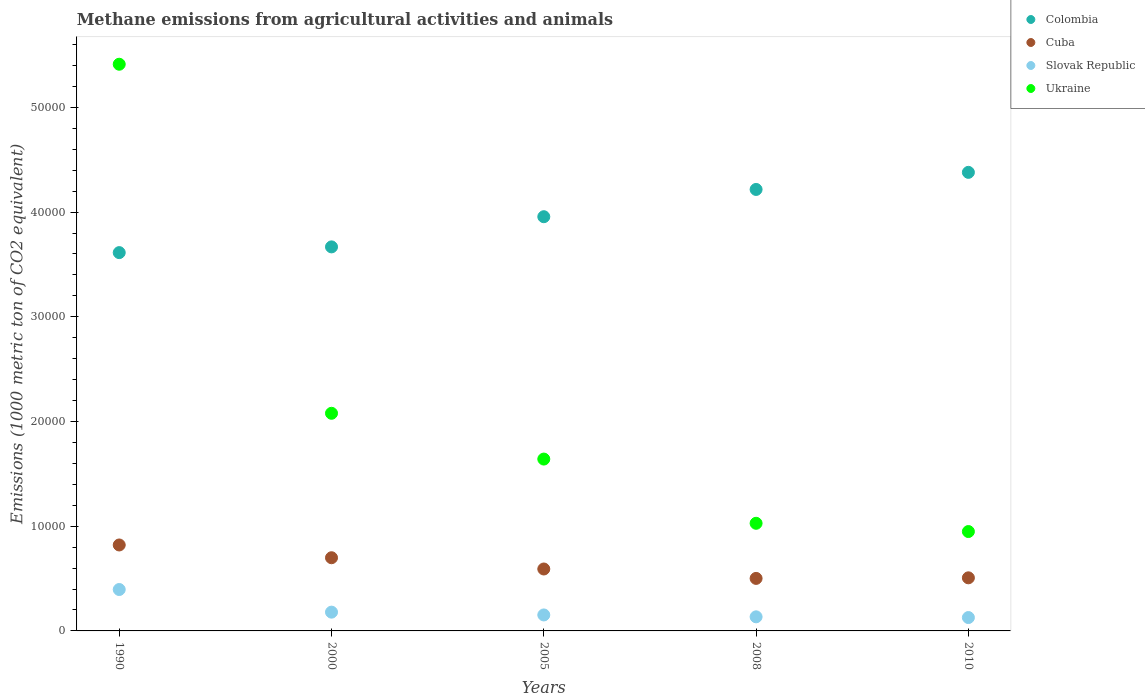What is the amount of methane emitted in Cuba in 2010?
Give a very brief answer. 5070.2. Across all years, what is the maximum amount of methane emitted in Ukraine?
Your answer should be very brief. 5.41e+04. Across all years, what is the minimum amount of methane emitted in Slovak Republic?
Keep it short and to the point. 1276.7. What is the total amount of methane emitted in Slovak Republic in the graph?
Your answer should be compact. 9896. What is the difference between the amount of methane emitted in Cuba in 1990 and that in 2008?
Ensure brevity in your answer.  3192.5. What is the difference between the amount of methane emitted in Cuba in 2000 and the amount of methane emitted in Slovak Republic in 2010?
Offer a terse response. 5711.6. What is the average amount of methane emitted in Cuba per year?
Give a very brief answer. 6238.96. In the year 1990, what is the difference between the amount of methane emitted in Slovak Republic and amount of methane emitted in Cuba?
Give a very brief answer. -4253. What is the ratio of the amount of methane emitted in Cuba in 1990 to that in 2008?
Make the answer very short. 1.64. Is the amount of methane emitted in Colombia in 2000 less than that in 2010?
Keep it short and to the point. Yes. Is the difference between the amount of methane emitted in Slovak Republic in 2000 and 2010 greater than the difference between the amount of methane emitted in Cuba in 2000 and 2010?
Keep it short and to the point. No. What is the difference between the highest and the second highest amount of methane emitted in Colombia?
Ensure brevity in your answer.  1632. What is the difference between the highest and the lowest amount of methane emitted in Colombia?
Provide a short and direct response. 7663.9. In how many years, is the amount of methane emitted in Colombia greater than the average amount of methane emitted in Colombia taken over all years?
Provide a succinct answer. 2. Is it the case that in every year, the sum of the amount of methane emitted in Slovak Republic and amount of methane emitted in Ukraine  is greater than the sum of amount of methane emitted in Colombia and amount of methane emitted in Cuba?
Your answer should be very brief. No. Does the amount of methane emitted in Slovak Republic monotonically increase over the years?
Provide a succinct answer. No. How many years are there in the graph?
Ensure brevity in your answer.  5. What is the difference between two consecutive major ticks on the Y-axis?
Offer a very short reply. 10000. Are the values on the major ticks of Y-axis written in scientific E-notation?
Provide a succinct answer. No. How many legend labels are there?
Your response must be concise. 4. How are the legend labels stacked?
Keep it short and to the point. Vertical. What is the title of the graph?
Give a very brief answer. Methane emissions from agricultural activities and animals. What is the label or title of the Y-axis?
Offer a terse response. Emissions (1000 metric ton of CO2 equivalent). What is the Emissions (1000 metric ton of CO2 equivalent) in Colombia in 1990?
Keep it short and to the point. 3.61e+04. What is the Emissions (1000 metric ton of CO2 equivalent) in Cuba in 1990?
Provide a succinct answer. 8207.5. What is the Emissions (1000 metric ton of CO2 equivalent) in Slovak Republic in 1990?
Offer a terse response. 3954.5. What is the Emissions (1000 metric ton of CO2 equivalent) in Ukraine in 1990?
Make the answer very short. 5.41e+04. What is the Emissions (1000 metric ton of CO2 equivalent) of Colombia in 2000?
Give a very brief answer. 3.67e+04. What is the Emissions (1000 metric ton of CO2 equivalent) in Cuba in 2000?
Your response must be concise. 6988.3. What is the Emissions (1000 metric ton of CO2 equivalent) of Slovak Republic in 2000?
Your response must be concise. 1793.2. What is the Emissions (1000 metric ton of CO2 equivalent) of Ukraine in 2000?
Ensure brevity in your answer.  2.08e+04. What is the Emissions (1000 metric ton of CO2 equivalent) of Colombia in 2005?
Offer a terse response. 3.96e+04. What is the Emissions (1000 metric ton of CO2 equivalent) in Cuba in 2005?
Provide a short and direct response. 5913.8. What is the Emissions (1000 metric ton of CO2 equivalent) of Slovak Republic in 2005?
Provide a short and direct response. 1525.9. What is the Emissions (1000 metric ton of CO2 equivalent) of Ukraine in 2005?
Offer a terse response. 1.64e+04. What is the Emissions (1000 metric ton of CO2 equivalent) in Colombia in 2008?
Make the answer very short. 4.22e+04. What is the Emissions (1000 metric ton of CO2 equivalent) in Cuba in 2008?
Your response must be concise. 5015. What is the Emissions (1000 metric ton of CO2 equivalent) of Slovak Republic in 2008?
Ensure brevity in your answer.  1345.7. What is the Emissions (1000 metric ton of CO2 equivalent) in Ukraine in 2008?
Provide a short and direct response. 1.03e+04. What is the Emissions (1000 metric ton of CO2 equivalent) in Colombia in 2010?
Your response must be concise. 4.38e+04. What is the Emissions (1000 metric ton of CO2 equivalent) in Cuba in 2010?
Make the answer very short. 5070.2. What is the Emissions (1000 metric ton of CO2 equivalent) in Slovak Republic in 2010?
Your answer should be very brief. 1276.7. What is the Emissions (1000 metric ton of CO2 equivalent) of Ukraine in 2010?
Your answer should be compact. 9489.8. Across all years, what is the maximum Emissions (1000 metric ton of CO2 equivalent) in Colombia?
Your answer should be very brief. 4.38e+04. Across all years, what is the maximum Emissions (1000 metric ton of CO2 equivalent) of Cuba?
Offer a terse response. 8207.5. Across all years, what is the maximum Emissions (1000 metric ton of CO2 equivalent) in Slovak Republic?
Make the answer very short. 3954.5. Across all years, what is the maximum Emissions (1000 metric ton of CO2 equivalent) of Ukraine?
Your answer should be compact. 5.41e+04. Across all years, what is the minimum Emissions (1000 metric ton of CO2 equivalent) in Colombia?
Make the answer very short. 3.61e+04. Across all years, what is the minimum Emissions (1000 metric ton of CO2 equivalent) of Cuba?
Ensure brevity in your answer.  5015. Across all years, what is the minimum Emissions (1000 metric ton of CO2 equivalent) in Slovak Republic?
Your answer should be very brief. 1276.7. Across all years, what is the minimum Emissions (1000 metric ton of CO2 equivalent) in Ukraine?
Offer a very short reply. 9489.8. What is the total Emissions (1000 metric ton of CO2 equivalent) of Colombia in the graph?
Offer a terse response. 1.98e+05. What is the total Emissions (1000 metric ton of CO2 equivalent) of Cuba in the graph?
Offer a terse response. 3.12e+04. What is the total Emissions (1000 metric ton of CO2 equivalent) in Slovak Republic in the graph?
Offer a very short reply. 9896. What is the total Emissions (1000 metric ton of CO2 equivalent) in Ukraine in the graph?
Offer a terse response. 1.11e+05. What is the difference between the Emissions (1000 metric ton of CO2 equivalent) in Colombia in 1990 and that in 2000?
Provide a short and direct response. -546.7. What is the difference between the Emissions (1000 metric ton of CO2 equivalent) in Cuba in 1990 and that in 2000?
Your response must be concise. 1219.2. What is the difference between the Emissions (1000 metric ton of CO2 equivalent) of Slovak Republic in 1990 and that in 2000?
Your answer should be very brief. 2161.3. What is the difference between the Emissions (1000 metric ton of CO2 equivalent) in Ukraine in 1990 and that in 2000?
Ensure brevity in your answer.  3.33e+04. What is the difference between the Emissions (1000 metric ton of CO2 equivalent) in Colombia in 1990 and that in 2005?
Provide a short and direct response. -3428.3. What is the difference between the Emissions (1000 metric ton of CO2 equivalent) in Cuba in 1990 and that in 2005?
Offer a terse response. 2293.7. What is the difference between the Emissions (1000 metric ton of CO2 equivalent) in Slovak Republic in 1990 and that in 2005?
Give a very brief answer. 2428.6. What is the difference between the Emissions (1000 metric ton of CO2 equivalent) in Ukraine in 1990 and that in 2005?
Make the answer very short. 3.77e+04. What is the difference between the Emissions (1000 metric ton of CO2 equivalent) in Colombia in 1990 and that in 2008?
Your answer should be very brief. -6031.9. What is the difference between the Emissions (1000 metric ton of CO2 equivalent) in Cuba in 1990 and that in 2008?
Offer a very short reply. 3192.5. What is the difference between the Emissions (1000 metric ton of CO2 equivalent) in Slovak Republic in 1990 and that in 2008?
Ensure brevity in your answer.  2608.8. What is the difference between the Emissions (1000 metric ton of CO2 equivalent) of Ukraine in 1990 and that in 2008?
Your answer should be compact. 4.38e+04. What is the difference between the Emissions (1000 metric ton of CO2 equivalent) of Colombia in 1990 and that in 2010?
Your answer should be compact. -7663.9. What is the difference between the Emissions (1000 metric ton of CO2 equivalent) in Cuba in 1990 and that in 2010?
Your answer should be very brief. 3137.3. What is the difference between the Emissions (1000 metric ton of CO2 equivalent) of Slovak Republic in 1990 and that in 2010?
Give a very brief answer. 2677.8. What is the difference between the Emissions (1000 metric ton of CO2 equivalent) in Ukraine in 1990 and that in 2010?
Ensure brevity in your answer.  4.46e+04. What is the difference between the Emissions (1000 metric ton of CO2 equivalent) of Colombia in 2000 and that in 2005?
Your answer should be very brief. -2881.6. What is the difference between the Emissions (1000 metric ton of CO2 equivalent) in Cuba in 2000 and that in 2005?
Provide a succinct answer. 1074.5. What is the difference between the Emissions (1000 metric ton of CO2 equivalent) of Slovak Republic in 2000 and that in 2005?
Your answer should be very brief. 267.3. What is the difference between the Emissions (1000 metric ton of CO2 equivalent) in Ukraine in 2000 and that in 2005?
Your answer should be compact. 4372.1. What is the difference between the Emissions (1000 metric ton of CO2 equivalent) of Colombia in 2000 and that in 2008?
Your answer should be very brief. -5485.2. What is the difference between the Emissions (1000 metric ton of CO2 equivalent) of Cuba in 2000 and that in 2008?
Ensure brevity in your answer.  1973.3. What is the difference between the Emissions (1000 metric ton of CO2 equivalent) of Slovak Republic in 2000 and that in 2008?
Offer a terse response. 447.5. What is the difference between the Emissions (1000 metric ton of CO2 equivalent) in Ukraine in 2000 and that in 2008?
Your response must be concise. 1.05e+04. What is the difference between the Emissions (1000 metric ton of CO2 equivalent) of Colombia in 2000 and that in 2010?
Provide a succinct answer. -7117.2. What is the difference between the Emissions (1000 metric ton of CO2 equivalent) of Cuba in 2000 and that in 2010?
Make the answer very short. 1918.1. What is the difference between the Emissions (1000 metric ton of CO2 equivalent) of Slovak Republic in 2000 and that in 2010?
Your answer should be compact. 516.5. What is the difference between the Emissions (1000 metric ton of CO2 equivalent) of Ukraine in 2000 and that in 2010?
Your answer should be very brief. 1.13e+04. What is the difference between the Emissions (1000 metric ton of CO2 equivalent) of Colombia in 2005 and that in 2008?
Give a very brief answer. -2603.6. What is the difference between the Emissions (1000 metric ton of CO2 equivalent) of Cuba in 2005 and that in 2008?
Keep it short and to the point. 898.8. What is the difference between the Emissions (1000 metric ton of CO2 equivalent) of Slovak Republic in 2005 and that in 2008?
Your answer should be very brief. 180.2. What is the difference between the Emissions (1000 metric ton of CO2 equivalent) of Ukraine in 2005 and that in 2008?
Provide a succinct answer. 6133.4. What is the difference between the Emissions (1000 metric ton of CO2 equivalent) of Colombia in 2005 and that in 2010?
Offer a terse response. -4235.6. What is the difference between the Emissions (1000 metric ton of CO2 equivalent) of Cuba in 2005 and that in 2010?
Offer a very short reply. 843.6. What is the difference between the Emissions (1000 metric ton of CO2 equivalent) in Slovak Republic in 2005 and that in 2010?
Provide a short and direct response. 249.2. What is the difference between the Emissions (1000 metric ton of CO2 equivalent) of Ukraine in 2005 and that in 2010?
Your answer should be compact. 6921.6. What is the difference between the Emissions (1000 metric ton of CO2 equivalent) in Colombia in 2008 and that in 2010?
Your answer should be very brief. -1632. What is the difference between the Emissions (1000 metric ton of CO2 equivalent) of Cuba in 2008 and that in 2010?
Your answer should be compact. -55.2. What is the difference between the Emissions (1000 metric ton of CO2 equivalent) of Slovak Republic in 2008 and that in 2010?
Your answer should be very brief. 69. What is the difference between the Emissions (1000 metric ton of CO2 equivalent) of Ukraine in 2008 and that in 2010?
Ensure brevity in your answer.  788.2. What is the difference between the Emissions (1000 metric ton of CO2 equivalent) in Colombia in 1990 and the Emissions (1000 metric ton of CO2 equivalent) in Cuba in 2000?
Provide a short and direct response. 2.91e+04. What is the difference between the Emissions (1000 metric ton of CO2 equivalent) in Colombia in 1990 and the Emissions (1000 metric ton of CO2 equivalent) in Slovak Republic in 2000?
Your answer should be very brief. 3.43e+04. What is the difference between the Emissions (1000 metric ton of CO2 equivalent) of Colombia in 1990 and the Emissions (1000 metric ton of CO2 equivalent) of Ukraine in 2000?
Make the answer very short. 1.53e+04. What is the difference between the Emissions (1000 metric ton of CO2 equivalent) of Cuba in 1990 and the Emissions (1000 metric ton of CO2 equivalent) of Slovak Republic in 2000?
Ensure brevity in your answer.  6414.3. What is the difference between the Emissions (1000 metric ton of CO2 equivalent) in Cuba in 1990 and the Emissions (1000 metric ton of CO2 equivalent) in Ukraine in 2000?
Your answer should be very brief. -1.26e+04. What is the difference between the Emissions (1000 metric ton of CO2 equivalent) of Slovak Republic in 1990 and the Emissions (1000 metric ton of CO2 equivalent) of Ukraine in 2000?
Provide a succinct answer. -1.68e+04. What is the difference between the Emissions (1000 metric ton of CO2 equivalent) in Colombia in 1990 and the Emissions (1000 metric ton of CO2 equivalent) in Cuba in 2005?
Keep it short and to the point. 3.02e+04. What is the difference between the Emissions (1000 metric ton of CO2 equivalent) of Colombia in 1990 and the Emissions (1000 metric ton of CO2 equivalent) of Slovak Republic in 2005?
Offer a terse response. 3.46e+04. What is the difference between the Emissions (1000 metric ton of CO2 equivalent) in Colombia in 1990 and the Emissions (1000 metric ton of CO2 equivalent) in Ukraine in 2005?
Offer a terse response. 1.97e+04. What is the difference between the Emissions (1000 metric ton of CO2 equivalent) in Cuba in 1990 and the Emissions (1000 metric ton of CO2 equivalent) in Slovak Republic in 2005?
Offer a very short reply. 6681.6. What is the difference between the Emissions (1000 metric ton of CO2 equivalent) in Cuba in 1990 and the Emissions (1000 metric ton of CO2 equivalent) in Ukraine in 2005?
Your response must be concise. -8203.9. What is the difference between the Emissions (1000 metric ton of CO2 equivalent) in Slovak Republic in 1990 and the Emissions (1000 metric ton of CO2 equivalent) in Ukraine in 2005?
Make the answer very short. -1.25e+04. What is the difference between the Emissions (1000 metric ton of CO2 equivalent) in Colombia in 1990 and the Emissions (1000 metric ton of CO2 equivalent) in Cuba in 2008?
Keep it short and to the point. 3.11e+04. What is the difference between the Emissions (1000 metric ton of CO2 equivalent) of Colombia in 1990 and the Emissions (1000 metric ton of CO2 equivalent) of Slovak Republic in 2008?
Offer a terse response. 3.48e+04. What is the difference between the Emissions (1000 metric ton of CO2 equivalent) in Colombia in 1990 and the Emissions (1000 metric ton of CO2 equivalent) in Ukraine in 2008?
Your answer should be very brief. 2.58e+04. What is the difference between the Emissions (1000 metric ton of CO2 equivalent) in Cuba in 1990 and the Emissions (1000 metric ton of CO2 equivalent) in Slovak Republic in 2008?
Ensure brevity in your answer.  6861.8. What is the difference between the Emissions (1000 metric ton of CO2 equivalent) of Cuba in 1990 and the Emissions (1000 metric ton of CO2 equivalent) of Ukraine in 2008?
Offer a terse response. -2070.5. What is the difference between the Emissions (1000 metric ton of CO2 equivalent) of Slovak Republic in 1990 and the Emissions (1000 metric ton of CO2 equivalent) of Ukraine in 2008?
Provide a succinct answer. -6323.5. What is the difference between the Emissions (1000 metric ton of CO2 equivalent) in Colombia in 1990 and the Emissions (1000 metric ton of CO2 equivalent) in Cuba in 2010?
Offer a terse response. 3.11e+04. What is the difference between the Emissions (1000 metric ton of CO2 equivalent) of Colombia in 1990 and the Emissions (1000 metric ton of CO2 equivalent) of Slovak Republic in 2010?
Provide a short and direct response. 3.49e+04. What is the difference between the Emissions (1000 metric ton of CO2 equivalent) in Colombia in 1990 and the Emissions (1000 metric ton of CO2 equivalent) in Ukraine in 2010?
Keep it short and to the point. 2.66e+04. What is the difference between the Emissions (1000 metric ton of CO2 equivalent) in Cuba in 1990 and the Emissions (1000 metric ton of CO2 equivalent) in Slovak Republic in 2010?
Your response must be concise. 6930.8. What is the difference between the Emissions (1000 metric ton of CO2 equivalent) of Cuba in 1990 and the Emissions (1000 metric ton of CO2 equivalent) of Ukraine in 2010?
Offer a very short reply. -1282.3. What is the difference between the Emissions (1000 metric ton of CO2 equivalent) in Slovak Republic in 1990 and the Emissions (1000 metric ton of CO2 equivalent) in Ukraine in 2010?
Offer a terse response. -5535.3. What is the difference between the Emissions (1000 metric ton of CO2 equivalent) in Colombia in 2000 and the Emissions (1000 metric ton of CO2 equivalent) in Cuba in 2005?
Make the answer very short. 3.08e+04. What is the difference between the Emissions (1000 metric ton of CO2 equivalent) of Colombia in 2000 and the Emissions (1000 metric ton of CO2 equivalent) of Slovak Republic in 2005?
Keep it short and to the point. 3.51e+04. What is the difference between the Emissions (1000 metric ton of CO2 equivalent) in Colombia in 2000 and the Emissions (1000 metric ton of CO2 equivalent) in Ukraine in 2005?
Your response must be concise. 2.03e+04. What is the difference between the Emissions (1000 metric ton of CO2 equivalent) of Cuba in 2000 and the Emissions (1000 metric ton of CO2 equivalent) of Slovak Republic in 2005?
Your answer should be compact. 5462.4. What is the difference between the Emissions (1000 metric ton of CO2 equivalent) in Cuba in 2000 and the Emissions (1000 metric ton of CO2 equivalent) in Ukraine in 2005?
Provide a short and direct response. -9423.1. What is the difference between the Emissions (1000 metric ton of CO2 equivalent) in Slovak Republic in 2000 and the Emissions (1000 metric ton of CO2 equivalent) in Ukraine in 2005?
Your response must be concise. -1.46e+04. What is the difference between the Emissions (1000 metric ton of CO2 equivalent) of Colombia in 2000 and the Emissions (1000 metric ton of CO2 equivalent) of Cuba in 2008?
Your answer should be compact. 3.17e+04. What is the difference between the Emissions (1000 metric ton of CO2 equivalent) of Colombia in 2000 and the Emissions (1000 metric ton of CO2 equivalent) of Slovak Republic in 2008?
Ensure brevity in your answer.  3.53e+04. What is the difference between the Emissions (1000 metric ton of CO2 equivalent) in Colombia in 2000 and the Emissions (1000 metric ton of CO2 equivalent) in Ukraine in 2008?
Make the answer very short. 2.64e+04. What is the difference between the Emissions (1000 metric ton of CO2 equivalent) in Cuba in 2000 and the Emissions (1000 metric ton of CO2 equivalent) in Slovak Republic in 2008?
Your response must be concise. 5642.6. What is the difference between the Emissions (1000 metric ton of CO2 equivalent) of Cuba in 2000 and the Emissions (1000 metric ton of CO2 equivalent) of Ukraine in 2008?
Keep it short and to the point. -3289.7. What is the difference between the Emissions (1000 metric ton of CO2 equivalent) of Slovak Republic in 2000 and the Emissions (1000 metric ton of CO2 equivalent) of Ukraine in 2008?
Provide a succinct answer. -8484.8. What is the difference between the Emissions (1000 metric ton of CO2 equivalent) of Colombia in 2000 and the Emissions (1000 metric ton of CO2 equivalent) of Cuba in 2010?
Your answer should be compact. 3.16e+04. What is the difference between the Emissions (1000 metric ton of CO2 equivalent) in Colombia in 2000 and the Emissions (1000 metric ton of CO2 equivalent) in Slovak Republic in 2010?
Your answer should be very brief. 3.54e+04. What is the difference between the Emissions (1000 metric ton of CO2 equivalent) in Colombia in 2000 and the Emissions (1000 metric ton of CO2 equivalent) in Ukraine in 2010?
Ensure brevity in your answer.  2.72e+04. What is the difference between the Emissions (1000 metric ton of CO2 equivalent) in Cuba in 2000 and the Emissions (1000 metric ton of CO2 equivalent) in Slovak Republic in 2010?
Keep it short and to the point. 5711.6. What is the difference between the Emissions (1000 metric ton of CO2 equivalent) of Cuba in 2000 and the Emissions (1000 metric ton of CO2 equivalent) of Ukraine in 2010?
Offer a very short reply. -2501.5. What is the difference between the Emissions (1000 metric ton of CO2 equivalent) of Slovak Republic in 2000 and the Emissions (1000 metric ton of CO2 equivalent) of Ukraine in 2010?
Give a very brief answer. -7696.6. What is the difference between the Emissions (1000 metric ton of CO2 equivalent) in Colombia in 2005 and the Emissions (1000 metric ton of CO2 equivalent) in Cuba in 2008?
Make the answer very short. 3.45e+04. What is the difference between the Emissions (1000 metric ton of CO2 equivalent) of Colombia in 2005 and the Emissions (1000 metric ton of CO2 equivalent) of Slovak Republic in 2008?
Provide a succinct answer. 3.82e+04. What is the difference between the Emissions (1000 metric ton of CO2 equivalent) in Colombia in 2005 and the Emissions (1000 metric ton of CO2 equivalent) in Ukraine in 2008?
Your response must be concise. 2.93e+04. What is the difference between the Emissions (1000 metric ton of CO2 equivalent) in Cuba in 2005 and the Emissions (1000 metric ton of CO2 equivalent) in Slovak Republic in 2008?
Provide a short and direct response. 4568.1. What is the difference between the Emissions (1000 metric ton of CO2 equivalent) of Cuba in 2005 and the Emissions (1000 metric ton of CO2 equivalent) of Ukraine in 2008?
Keep it short and to the point. -4364.2. What is the difference between the Emissions (1000 metric ton of CO2 equivalent) in Slovak Republic in 2005 and the Emissions (1000 metric ton of CO2 equivalent) in Ukraine in 2008?
Offer a terse response. -8752.1. What is the difference between the Emissions (1000 metric ton of CO2 equivalent) in Colombia in 2005 and the Emissions (1000 metric ton of CO2 equivalent) in Cuba in 2010?
Provide a succinct answer. 3.45e+04. What is the difference between the Emissions (1000 metric ton of CO2 equivalent) of Colombia in 2005 and the Emissions (1000 metric ton of CO2 equivalent) of Slovak Republic in 2010?
Offer a very short reply. 3.83e+04. What is the difference between the Emissions (1000 metric ton of CO2 equivalent) of Colombia in 2005 and the Emissions (1000 metric ton of CO2 equivalent) of Ukraine in 2010?
Offer a terse response. 3.01e+04. What is the difference between the Emissions (1000 metric ton of CO2 equivalent) of Cuba in 2005 and the Emissions (1000 metric ton of CO2 equivalent) of Slovak Republic in 2010?
Make the answer very short. 4637.1. What is the difference between the Emissions (1000 metric ton of CO2 equivalent) of Cuba in 2005 and the Emissions (1000 metric ton of CO2 equivalent) of Ukraine in 2010?
Your answer should be compact. -3576. What is the difference between the Emissions (1000 metric ton of CO2 equivalent) in Slovak Republic in 2005 and the Emissions (1000 metric ton of CO2 equivalent) in Ukraine in 2010?
Provide a short and direct response. -7963.9. What is the difference between the Emissions (1000 metric ton of CO2 equivalent) of Colombia in 2008 and the Emissions (1000 metric ton of CO2 equivalent) of Cuba in 2010?
Make the answer very short. 3.71e+04. What is the difference between the Emissions (1000 metric ton of CO2 equivalent) of Colombia in 2008 and the Emissions (1000 metric ton of CO2 equivalent) of Slovak Republic in 2010?
Your answer should be compact. 4.09e+04. What is the difference between the Emissions (1000 metric ton of CO2 equivalent) of Colombia in 2008 and the Emissions (1000 metric ton of CO2 equivalent) of Ukraine in 2010?
Offer a very short reply. 3.27e+04. What is the difference between the Emissions (1000 metric ton of CO2 equivalent) of Cuba in 2008 and the Emissions (1000 metric ton of CO2 equivalent) of Slovak Republic in 2010?
Ensure brevity in your answer.  3738.3. What is the difference between the Emissions (1000 metric ton of CO2 equivalent) of Cuba in 2008 and the Emissions (1000 metric ton of CO2 equivalent) of Ukraine in 2010?
Keep it short and to the point. -4474.8. What is the difference between the Emissions (1000 metric ton of CO2 equivalent) in Slovak Republic in 2008 and the Emissions (1000 metric ton of CO2 equivalent) in Ukraine in 2010?
Your response must be concise. -8144.1. What is the average Emissions (1000 metric ton of CO2 equivalent) of Colombia per year?
Provide a succinct answer. 3.97e+04. What is the average Emissions (1000 metric ton of CO2 equivalent) in Cuba per year?
Keep it short and to the point. 6238.96. What is the average Emissions (1000 metric ton of CO2 equivalent) in Slovak Republic per year?
Offer a terse response. 1979.2. What is the average Emissions (1000 metric ton of CO2 equivalent) of Ukraine per year?
Provide a short and direct response. 2.22e+04. In the year 1990, what is the difference between the Emissions (1000 metric ton of CO2 equivalent) in Colombia and Emissions (1000 metric ton of CO2 equivalent) in Cuba?
Offer a very short reply. 2.79e+04. In the year 1990, what is the difference between the Emissions (1000 metric ton of CO2 equivalent) in Colombia and Emissions (1000 metric ton of CO2 equivalent) in Slovak Republic?
Make the answer very short. 3.22e+04. In the year 1990, what is the difference between the Emissions (1000 metric ton of CO2 equivalent) of Colombia and Emissions (1000 metric ton of CO2 equivalent) of Ukraine?
Make the answer very short. -1.80e+04. In the year 1990, what is the difference between the Emissions (1000 metric ton of CO2 equivalent) of Cuba and Emissions (1000 metric ton of CO2 equivalent) of Slovak Republic?
Make the answer very short. 4253. In the year 1990, what is the difference between the Emissions (1000 metric ton of CO2 equivalent) in Cuba and Emissions (1000 metric ton of CO2 equivalent) in Ukraine?
Provide a succinct answer. -4.59e+04. In the year 1990, what is the difference between the Emissions (1000 metric ton of CO2 equivalent) of Slovak Republic and Emissions (1000 metric ton of CO2 equivalent) of Ukraine?
Give a very brief answer. -5.02e+04. In the year 2000, what is the difference between the Emissions (1000 metric ton of CO2 equivalent) in Colombia and Emissions (1000 metric ton of CO2 equivalent) in Cuba?
Offer a very short reply. 2.97e+04. In the year 2000, what is the difference between the Emissions (1000 metric ton of CO2 equivalent) of Colombia and Emissions (1000 metric ton of CO2 equivalent) of Slovak Republic?
Your answer should be very brief. 3.49e+04. In the year 2000, what is the difference between the Emissions (1000 metric ton of CO2 equivalent) of Colombia and Emissions (1000 metric ton of CO2 equivalent) of Ukraine?
Provide a short and direct response. 1.59e+04. In the year 2000, what is the difference between the Emissions (1000 metric ton of CO2 equivalent) in Cuba and Emissions (1000 metric ton of CO2 equivalent) in Slovak Republic?
Make the answer very short. 5195.1. In the year 2000, what is the difference between the Emissions (1000 metric ton of CO2 equivalent) in Cuba and Emissions (1000 metric ton of CO2 equivalent) in Ukraine?
Offer a terse response. -1.38e+04. In the year 2000, what is the difference between the Emissions (1000 metric ton of CO2 equivalent) in Slovak Republic and Emissions (1000 metric ton of CO2 equivalent) in Ukraine?
Your response must be concise. -1.90e+04. In the year 2005, what is the difference between the Emissions (1000 metric ton of CO2 equivalent) in Colombia and Emissions (1000 metric ton of CO2 equivalent) in Cuba?
Keep it short and to the point. 3.36e+04. In the year 2005, what is the difference between the Emissions (1000 metric ton of CO2 equivalent) of Colombia and Emissions (1000 metric ton of CO2 equivalent) of Slovak Republic?
Offer a terse response. 3.80e+04. In the year 2005, what is the difference between the Emissions (1000 metric ton of CO2 equivalent) in Colombia and Emissions (1000 metric ton of CO2 equivalent) in Ukraine?
Give a very brief answer. 2.31e+04. In the year 2005, what is the difference between the Emissions (1000 metric ton of CO2 equivalent) of Cuba and Emissions (1000 metric ton of CO2 equivalent) of Slovak Republic?
Provide a short and direct response. 4387.9. In the year 2005, what is the difference between the Emissions (1000 metric ton of CO2 equivalent) in Cuba and Emissions (1000 metric ton of CO2 equivalent) in Ukraine?
Offer a very short reply. -1.05e+04. In the year 2005, what is the difference between the Emissions (1000 metric ton of CO2 equivalent) of Slovak Republic and Emissions (1000 metric ton of CO2 equivalent) of Ukraine?
Keep it short and to the point. -1.49e+04. In the year 2008, what is the difference between the Emissions (1000 metric ton of CO2 equivalent) in Colombia and Emissions (1000 metric ton of CO2 equivalent) in Cuba?
Your answer should be compact. 3.71e+04. In the year 2008, what is the difference between the Emissions (1000 metric ton of CO2 equivalent) of Colombia and Emissions (1000 metric ton of CO2 equivalent) of Slovak Republic?
Keep it short and to the point. 4.08e+04. In the year 2008, what is the difference between the Emissions (1000 metric ton of CO2 equivalent) in Colombia and Emissions (1000 metric ton of CO2 equivalent) in Ukraine?
Offer a terse response. 3.19e+04. In the year 2008, what is the difference between the Emissions (1000 metric ton of CO2 equivalent) in Cuba and Emissions (1000 metric ton of CO2 equivalent) in Slovak Republic?
Ensure brevity in your answer.  3669.3. In the year 2008, what is the difference between the Emissions (1000 metric ton of CO2 equivalent) of Cuba and Emissions (1000 metric ton of CO2 equivalent) of Ukraine?
Ensure brevity in your answer.  -5263. In the year 2008, what is the difference between the Emissions (1000 metric ton of CO2 equivalent) of Slovak Republic and Emissions (1000 metric ton of CO2 equivalent) of Ukraine?
Make the answer very short. -8932.3. In the year 2010, what is the difference between the Emissions (1000 metric ton of CO2 equivalent) of Colombia and Emissions (1000 metric ton of CO2 equivalent) of Cuba?
Give a very brief answer. 3.87e+04. In the year 2010, what is the difference between the Emissions (1000 metric ton of CO2 equivalent) in Colombia and Emissions (1000 metric ton of CO2 equivalent) in Slovak Republic?
Ensure brevity in your answer.  4.25e+04. In the year 2010, what is the difference between the Emissions (1000 metric ton of CO2 equivalent) of Colombia and Emissions (1000 metric ton of CO2 equivalent) of Ukraine?
Give a very brief answer. 3.43e+04. In the year 2010, what is the difference between the Emissions (1000 metric ton of CO2 equivalent) of Cuba and Emissions (1000 metric ton of CO2 equivalent) of Slovak Republic?
Ensure brevity in your answer.  3793.5. In the year 2010, what is the difference between the Emissions (1000 metric ton of CO2 equivalent) in Cuba and Emissions (1000 metric ton of CO2 equivalent) in Ukraine?
Provide a succinct answer. -4419.6. In the year 2010, what is the difference between the Emissions (1000 metric ton of CO2 equivalent) in Slovak Republic and Emissions (1000 metric ton of CO2 equivalent) in Ukraine?
Keep it short and to the point. -8213.1. What is the ratio of the Emissions (1000 metric ton of CO2 equivalent) in Colombia in 1990 to that in 2000?
Your answer should be compact. 0.99. What is the ratio of the Emissions (1000 metric ton of CO2 equivalent) of Cuba in 1990 to that in 2000?
Your answer should be compact. 1.17. What is the ratio of the Emissions (1000 metric ton of CO2 equivalent) in Slovak Republic in 1990 to that in 2000?
Keep it short and to the point. 2.21. What is the ratio of the Emissions (1000 metric ton of CO2 equivalent) of Ukraine in 1990 to that in 2000?
Give a very brief answer. 2.6. What is the ratio of the Emissions (1000 metric ton of CO2 equivalent) of Colombia in 1990 to that in 2005?
Keep it short and to the point. 0.91. What is the ratio of the Emissions (1000 metric ton of CO2 equivalent) in Cuba in 1990 to that in 2005?
Provide a succinct answer. 1.39. What is the ratio of the Emissions (1000 metric ton of CO2 equivalent) in Slovak Republic in 1990 to that in 2005?
Ensure brevity in your answer.  2.59. What is the ratio of the Emissions (1000 metric ton of CO2 equivalent) of Ukraine in 1990 to that in 2005?
Provide a short and direct response. 3.3. What is the ratio of the Emissions (1000 metric ton of CO2 equivalent) in Colombia in 1990 to that in 2008?
Keep it short and to the point. 0.86. What is the ratio of the Emissions (1000 metric ton of CO2 equivalent) in Cuba in 1990 to that in 2008?
Provide a succinct answer. 1.64. What is the ratio of the Emissions (1000 metric ton of CO2 equivalent) in Slovak Republic in 1990 to that in 2008?
Provide a short and direct response. 2.94. What is the ratio of the Emissions (1000 metric ton of CO2 equivalent) in Ukraine in 1990 to that in 2008?
Keep it short and to the point. 5.27. What is the ratio of the Emissions (1000 metric ton of CO2 equivalent) in Colombia in 1990 to that in 2010?
Offer a very short reply. 0.82. What is the ratio of the Emissions (1000 metric ton of CO2 equivalent) in Cuba in 1990 to that in 2010?
Give a very brief answer. 1.62. What is the ratio of the Emissions (1000 metric ton of CO2 equivalent) of Slovak Republic in 1990 to that in 2010?
Your response must be concise. 3.1. What is the ratio of the Emissions (1000 metric ton of CO2 equivalent) of Ukraine in 1990 to that in 2010?
Your answer should be very brief. 5.7. What is the ratio of the Emissions (1000 metric ton of CO2 equivalent) in Colombia in 2000 to that in 2005?
Ensure brevity in your answer.  0.93. What is the ratio of the Emissions (1000 metric ton of CO2 equivalent) in Cuba in 2000 to that in 2005?
Offer a very short reply. 1.18. What is the ratio of the Emissions (1000 metric ton of CO2 equivalent) of Slovak Republic in 2000 to that in 2005?
Make the answer very short. 1.18. What is the ratio of the Emissions (1000 metric ton of CO2 equivalent) in Ukraine in 2000 to that in 2005?
Ensure brevity in your answer.  1.27. What is the ratio of the Emissions (1000 metric ton of CO2 equivalent) in Colombia in 2000 to that in 2008?
Provide a succinct answer. 0.87. What is the ratio of the Emissions (1000 metric ton of CO2 equivalent) of Cuba in 2000 to that in 2008?
Make the answer very short. 1.39. What is the ratio of the Emissions (1000 metric ton of CO2 equivalent) in Slovak Republic in 2000 to that in 2008?
Give a very brief answer. 1.33. What is the ratio of the Emissions (1000 metric ton of CO2 equivalent) in Ukraine in 2000 to that in 2008?
Offer a terse response. 2.02. What is the ratio of the Emissions (1000 metric ton of CO2 equivalent) in Colombia in 2000 to that in 2010?
Provide a succinct answer. 0.84. What is the ratio of the Emissions (1000 metric ton of CO2 equivalent) in Cuba in 2000 to that in 2010?
Provide a short and direct response. 1.38. What is the ratio of the Emissions (1000 metric ton of CO2 equivalent) of Slovak Republic in 2000 to that in 2010?
Keep it short and to the point. 1.4. What is the ratio of the Emissions (1000 metric ton of CO2 equivalent) of Ukraine in 2000 to that in 2010?
Provide a short and direct response. 2.19. What is the ratio of the Emissions (1000 metric ton of CO2 equivalent) in Colombia in 2005 to that in 2008?
Your response must be concise. 0.94. What is the ratio of the Emissions (1000 metric ton of CO2 equivalent) of Cuba in 2005 to that in 2008?
Keep it short and to the point. 1.18. What is the ratio of the Emissions (1000 metric ton of CO2 equivalent) of Slovak Republic in 2005 to that in 2008?
Keep it short and to the point. 1.13. What is the ratio of the Emissions (1000 metric ton of CO2 equivalent) in Ukraine in 2005 to that in 2008?
Offer a very short reply. 1.6. What is the ratio of the Emissions (1000 metric ton of CO2 equivalent) of Colombia in 2005 to that in 2010?
Provide a succinct answer. 0.9. What is the ratio of the Emissions (1000 metric ton of CO2 equivalent) of Cuba in 2005 to that in 2010?
Provide a succinct answer. 1.17. What is the ratio of the Emissions (1000 metric ton of CO2 equivalent) of Slovak Republic in 2005 to that in 2010?
Make the answer very short. 1.2. What is the ratio of the Emissions (1000 metric ton of CO2 equivalent) in Ukraine in 2005 to that in 2010?
Give a very brief answer. 1.73. What is the ratio of the Emissions (1000 metric ton of CO2 equivalent) of Colombia in 2008 to that in 2010?
Provide a succinct answer. 0.96. What is the ratio of the Emissions (1000 metric ton of CO2 equivalent) in Cuba in 2008 to that in 2010?
Your response must be concise. 0.99. What is the ratio of the Emissions (1000 metric ton of CO2 equivalent) in Slovak Republic in 2008 to that in 2010?
Offer a very short reply. 1.05. What is the ratio of the Emissions (1000 metric ton of CO2 equivalent) of Ukraine in 2008 to that in 2010?
Your response must be concise. 1.08. What is the difference between the highest and the second highest Emissions (1000 metric ton of CO2 equivalent) of Colombia?
Keep it short and to the point. 1632. What is the difference between the highest and the second highest Emissions (1000 metric ton of CO2 equivalent) in Cuba?
Make the answer very short. 1219.2. What is the difference between the highest and the second highest Emissions (1000 metric ton of CO2 equivalent) in Slovak Republic?
Keep it short and to the point. 2161.3. What is the difference between the highest and the second highest Emissions (1000 metric ton of CO2 equivalent) in Ukraine?
Offer a very short reply. 3.33e+04. What is the difference between the highest and the lowest Emissions (1000 metric ton of CO2 equivalent) of Colombia?
Offer a very short reply. 7663.9. What is the difference between the highest and the lowest Emissions (1000 metric ton of CO2 equivalent) in Cuba?
Keep it short and to the point. 3192.5. What is the difference between the highest and the lowest Emissions (1000 metric ton of CO2 equivalent) in Slovak Republic?
Your answer should be very brief. 2677.8. What is the difference between the highest and the lowest Emissions (1000 metric ton of CO2 equivalent) of Ukraine?
Keep it short and to the point. 4.46e+04. 